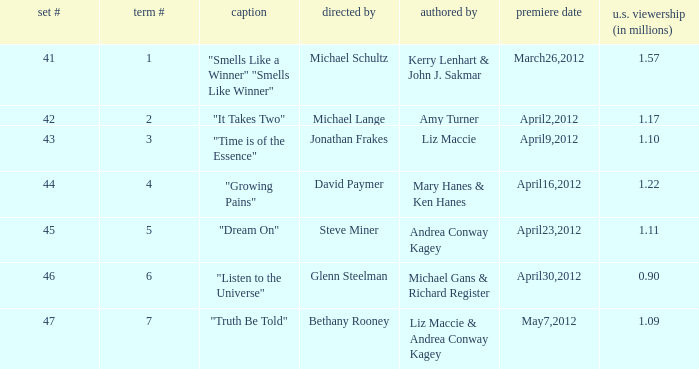When was the first broadcast of the episode titled "Truth Be Told"? May7,2012. 